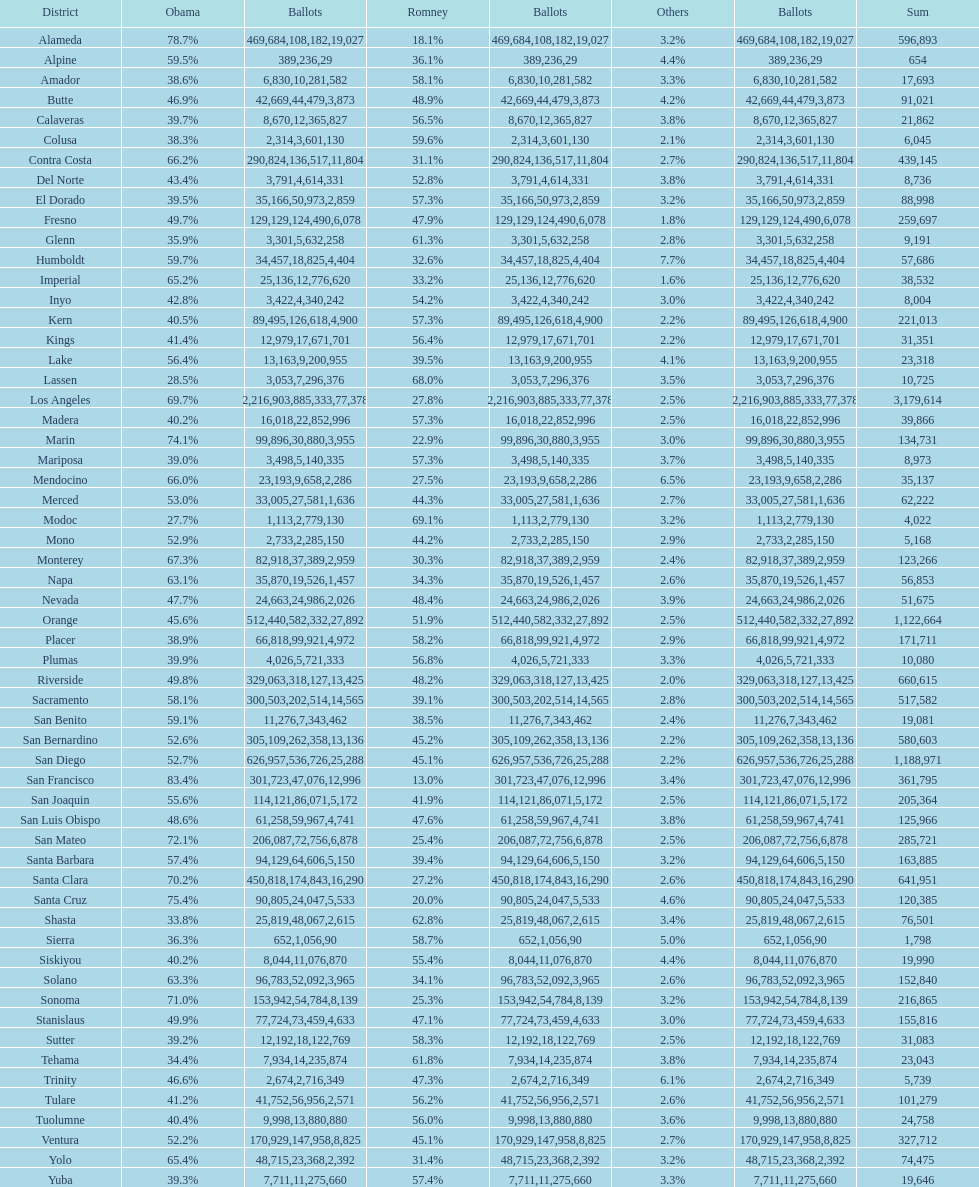Which count had the least number of votes for obama? Modoc. 